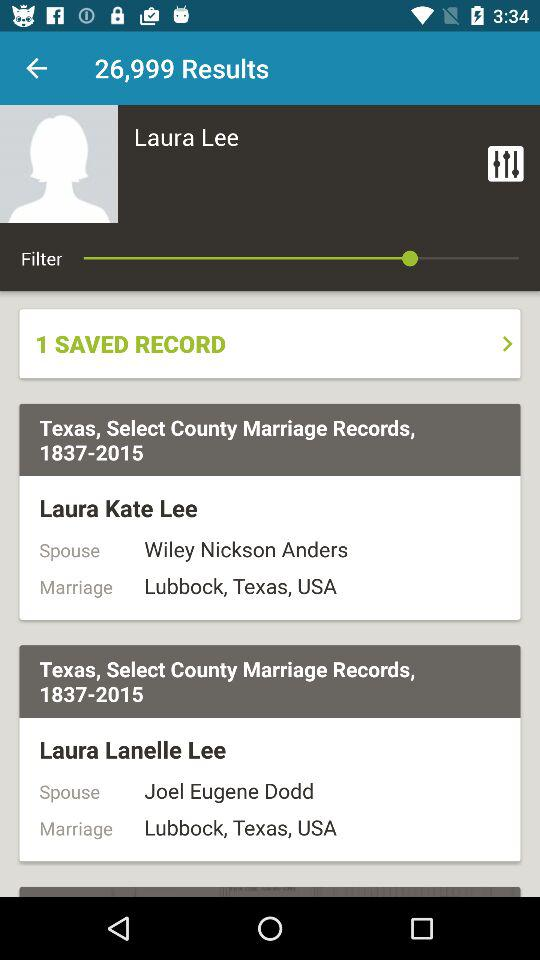What is the name of the spouse of Laura Kate Lee? The name of the spouse of Laura Kate Lee is Wiley Nickson Anders. 